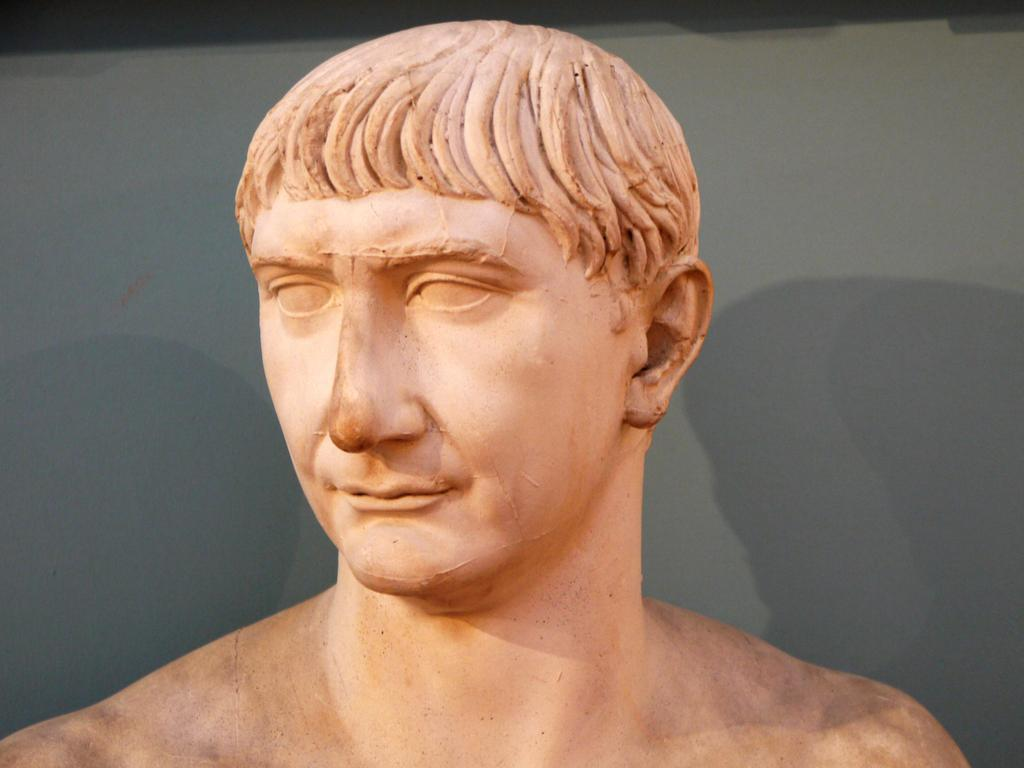What is the main subject in the center of the image? There is a statue in the center of the image. What can be seen in the background of the image? There is a wall visible in the background of the image. What type of circle is depicted on the statue in the image? There is no circle depicted on the statue in the image. What type of bag is being used to carry the statue in the image? There is no bag present in the image, and the statue is stationary. 